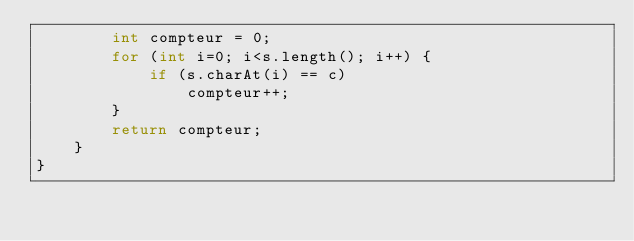<code> <loc_0><loc_0><loc_500><loc_500><_Java_>        int compteur = 0;
        for (int i=0; i<s.length(); i++) {
            if (s.charAt(i) == c)
                compteur++;
        }
        return compteur;
    }
}</code> 